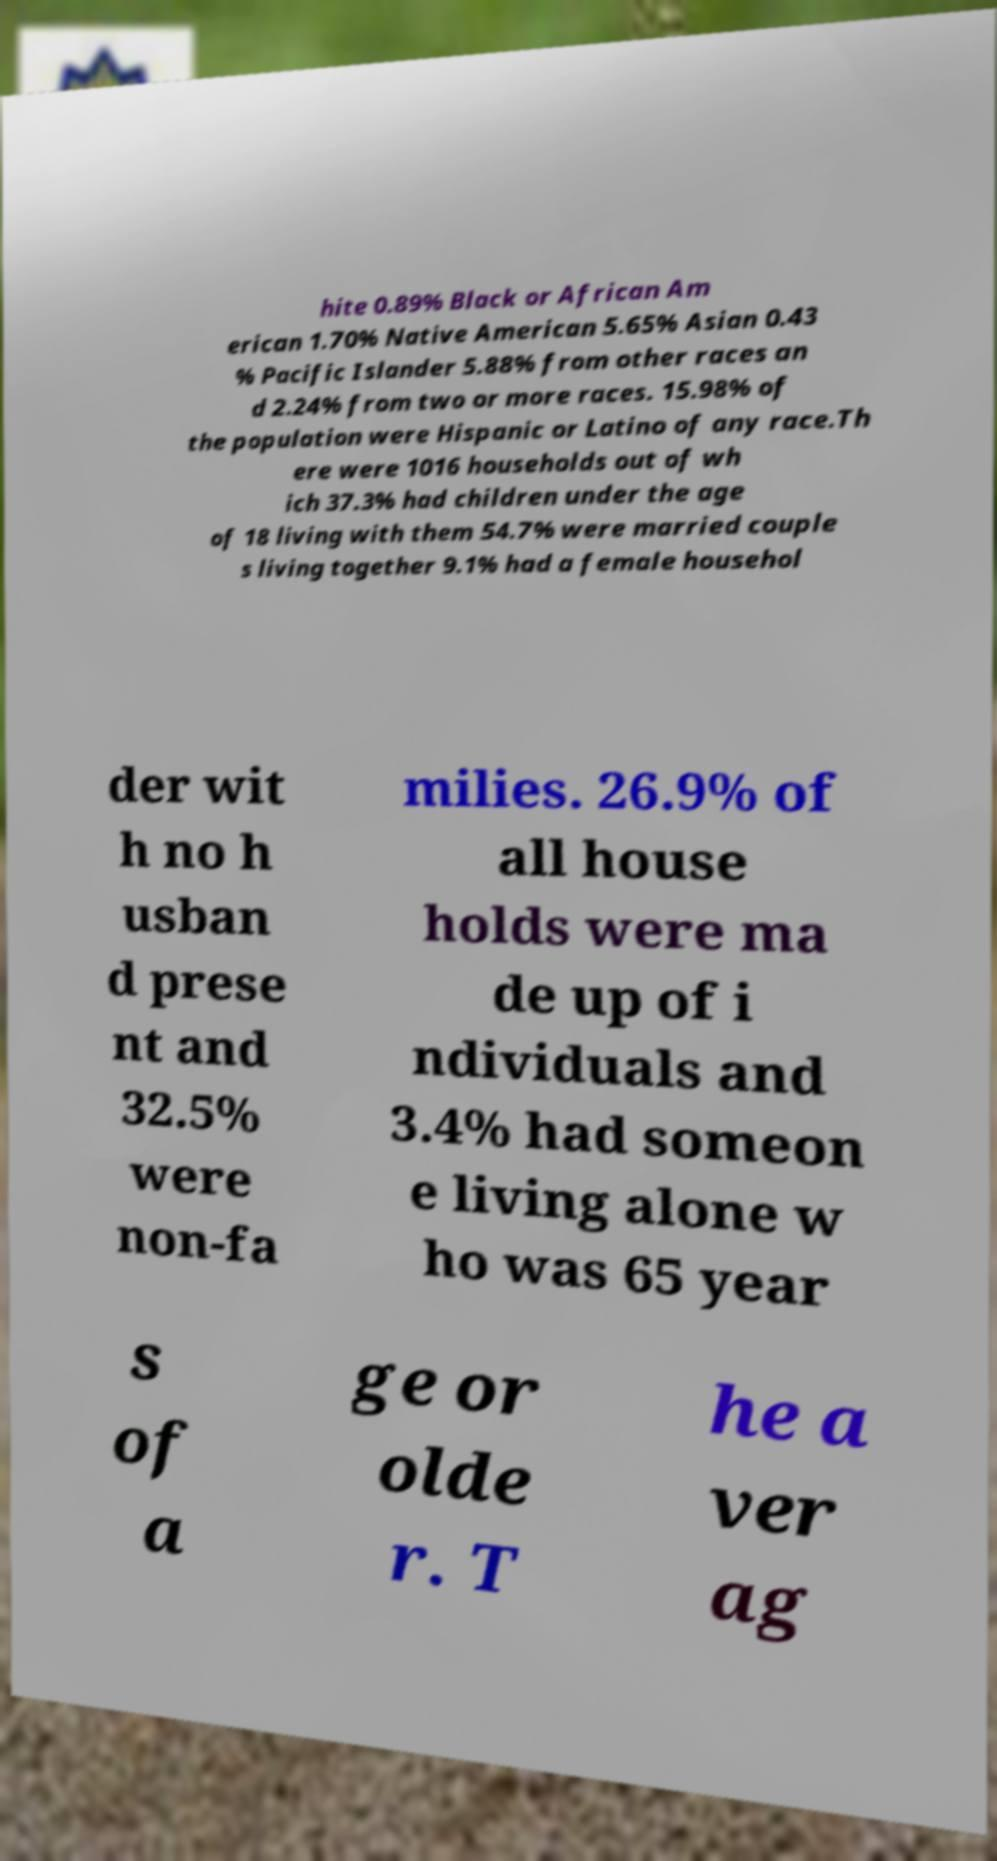What messages or text are displayed in this image? I need them in a readable, typed format. hite 0.89% Black or African Am erican 1.70% Native American 5.65% Asian 0.43 % Pacific Islander 5.88% from other races an d 2.24% from two or more races. 15.98% of the population were Hispanic or Latino of any race.Th ere were 1016 households out of wh ich 37.3% had children under the age of 18 living with them 54.7% were married couple s living together 9.1% had a female househol der wit h no h usban d prese nt and 32.5% were non-fa milies. 26.9% of all house holds were ma de up of i ndividuals and 3.4% had someon e living alone w ho was 65 year s of a ge or olde r. T he a ver ag 